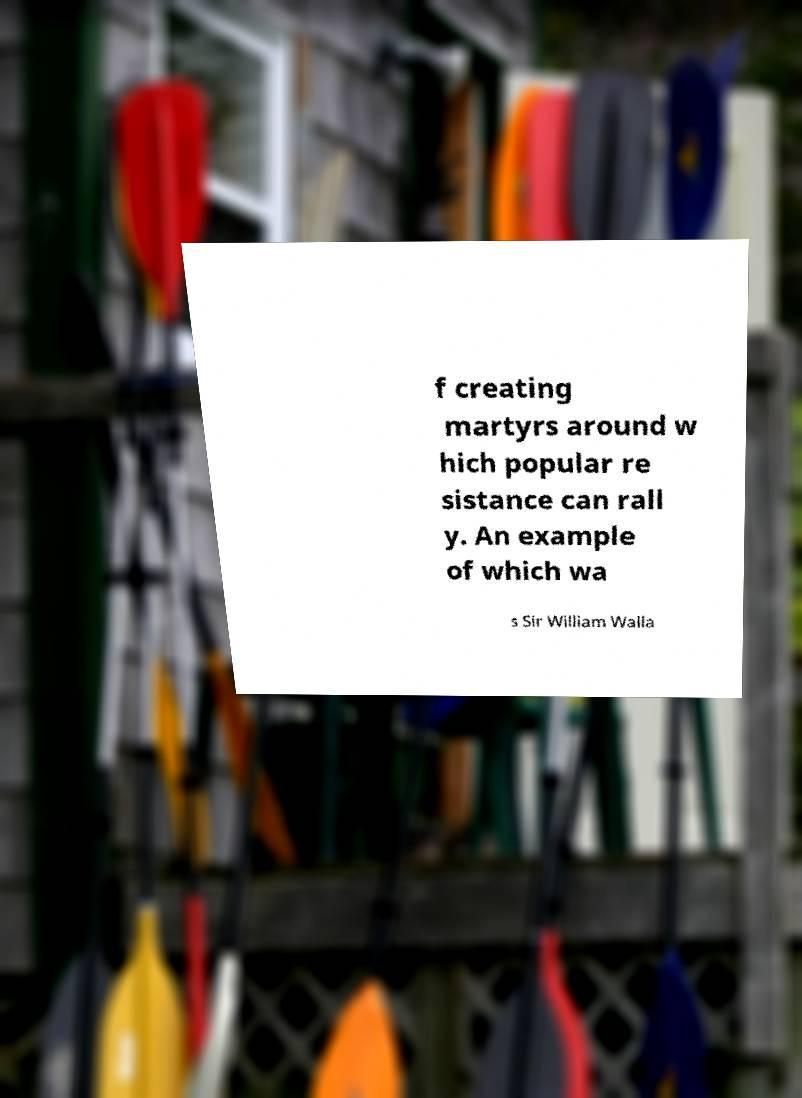Please read and relay the text visible in this image. What does it say? f creating martyrs around w hich popular re sistance can rall y. An example of which wa s Sir William Walla 